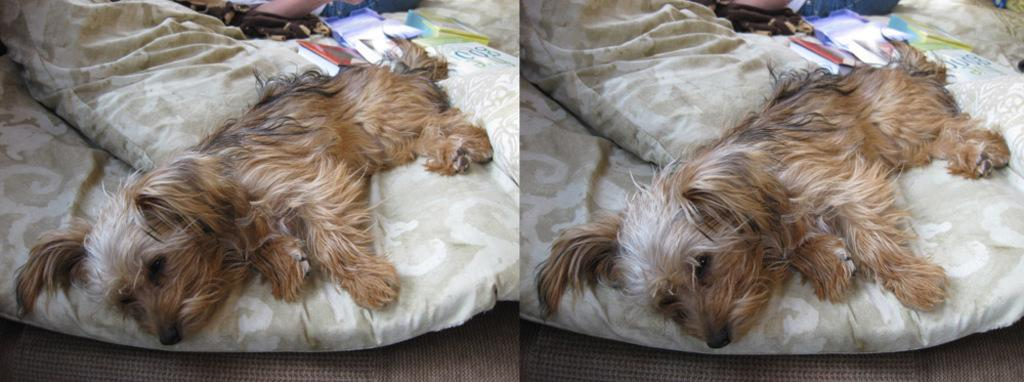What animal is laying on the bed in the image? There is a dog laying on the bed. What else can be seen on the bed besides the dog? There are books and a pillow on the bed. How many people are lying on the bed in the image? There is another person lying on the bed. What type of tooth is visible in the image? There is no tooth visible in the image. How old is the daughter in the image? There is no daughter present in the image. 